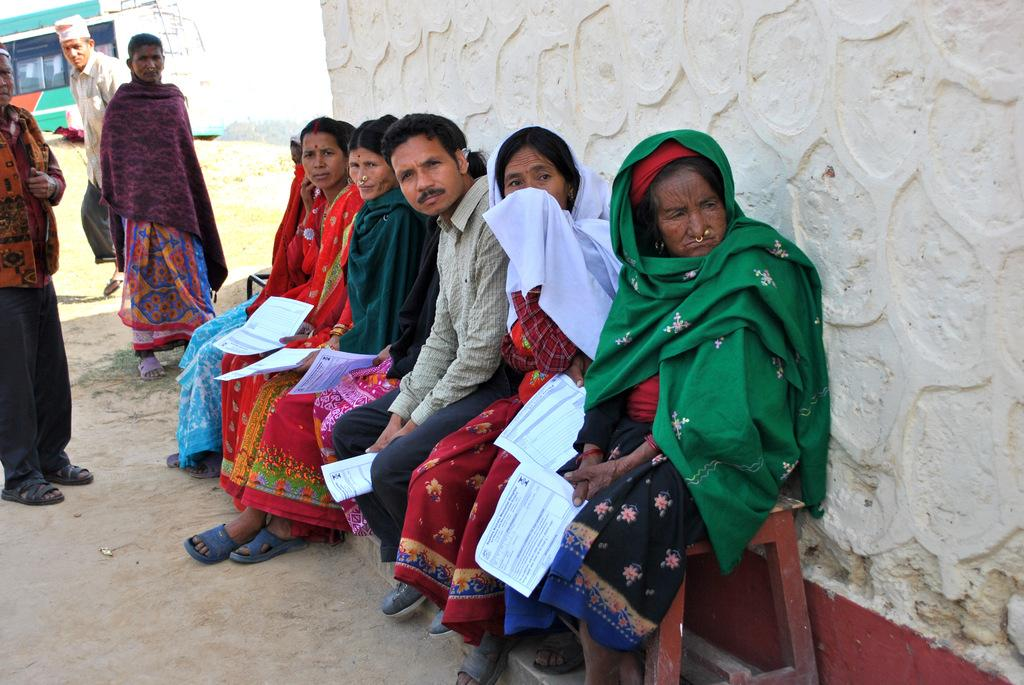What are the people in the image doing? There are people sitting on a bench and standing in the image. What might the people holding papers be doing? Some of the people are holding papers, which might suggest they are discussing or working on something. What can be seen in the background of the image? There is a wall, a bus, and the sky visible in the background of the image. What type of crime is being committed in the image? There is no indication of a crime being committed in the image. Can you tell me how many yaks are present in the image? There are no yaks present in the image. 